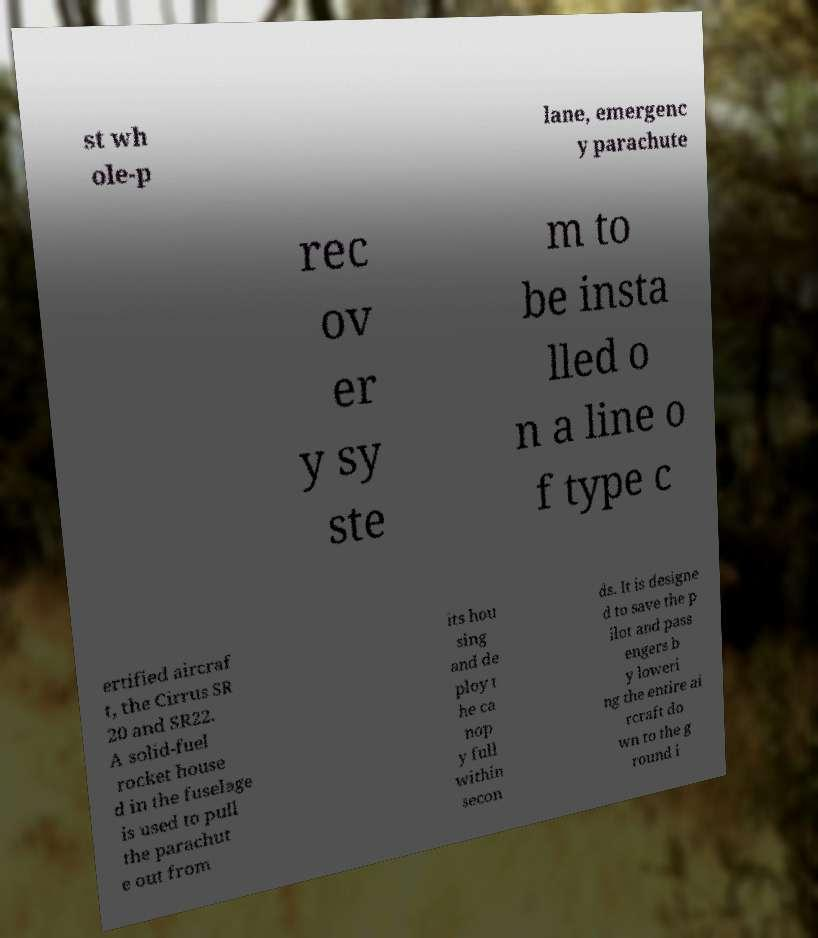Please read and relay the text visible in this image. What does it say? st wh ole-p lane, emergenc y parachute rec ov er y sy ste m to be insta lled o n a line o f type c ertified aircraf t, the Cirrus SR 20 and SR22. A solid-fuel rocket house d in the fuselage is used to pull the parachut e out from its hou sing and de ploy t he ca nop y full within secon ds. It is designe d to save the p ilot and pass engers b y loweri ng the entire ai rcraft do wn to the g round i 